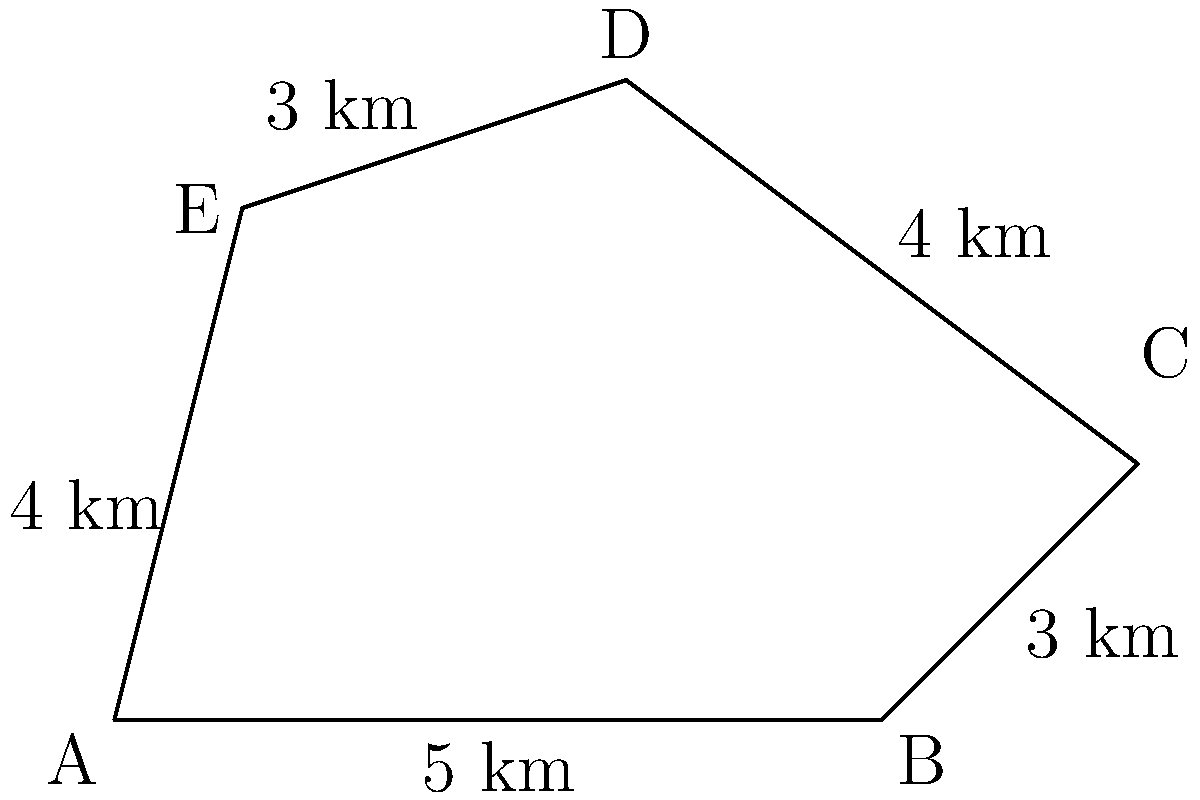A new hunting zone has been proposed in the shape of an irregular pentagon ABCDE, as shown in the diagram. The sides of the pentagon represent the boundaries of the zone, with lengths given in kilometers. Calculate the area of this hunting zone in square kilometers. To calculate the area of this irregular polygon, we can use the shoelace formula (also known as the surveyor's formula). The steps are as follows:

1) Label the vertices in counterclockwise order: A(0,0), B(6,0), C(8,2), D(4,5), E(1,4).

2) Apply the shoelace formula:
   Area = $\frac{1}{2}|[(x_1y_2 + x_2y_3 + x_3y_4 + x_4y_5 + x_5y_1) - (y_1x_2 + y_2x_3 + y_3x_4 + y_4x_5 + y_5x_1)]|$

3) Substitute the coordinates:
   Area = $\frac{1}{2}|[(0 \cdot 0 + 6 \cdot 2 + 8 \cdot 5 + 4 \cdot 4 + 1 \cdot 0) - (0 \cdot 6 + 0 \cdot 8 + 2 \cdot 4 + 5 \cdot 1 + 4 \cdot 0)]|$

4) Simplify:
   Area = $\frac{1}{2}|[(0 + 12 + 40 + 16 + 0) - (0 + 0 + 8 + 5 + 0)]|$
   Area = $\frac{1}{2}|[68 - 13]|$
   Area = $\frac{1}{2}|55|$
   Area = $\frac{55}{2}$ = 27.5

Therefore, the area of the hunting zone is 27.5 square kilometers.
Answer: 27.5 sq km 